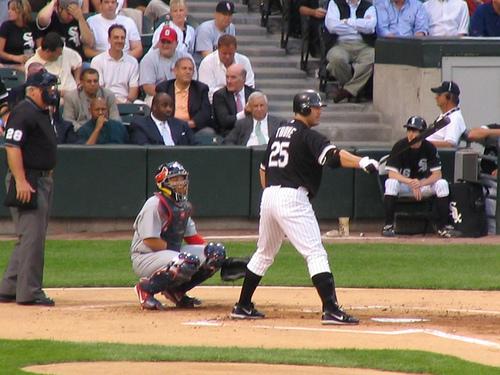Who is the batter?
Be succinct. 25. Does this batter swing left handed?
Quick response, please. Yes. How many people are wearing baseball hats?
Concise answer only. 4. 